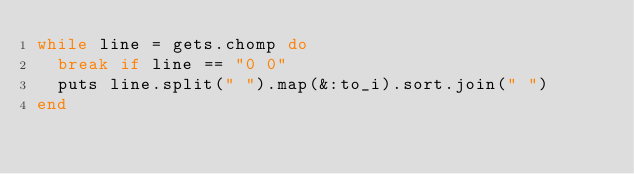<code> <loc_0><loc_0><loc_500><loc_500><_Ruby_>while line = gets.chomp do
  break if line == "0 0"
  puts line.split(" ").map(&:to_i).sort.join(" ")
end</code> 